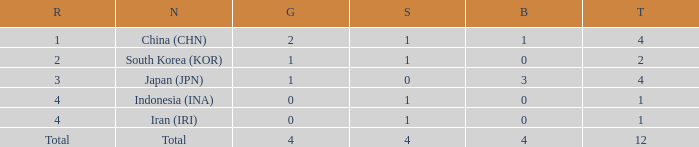How many silver medals for the nation with fewer than 1 golds and total less than 1? 0.0. 